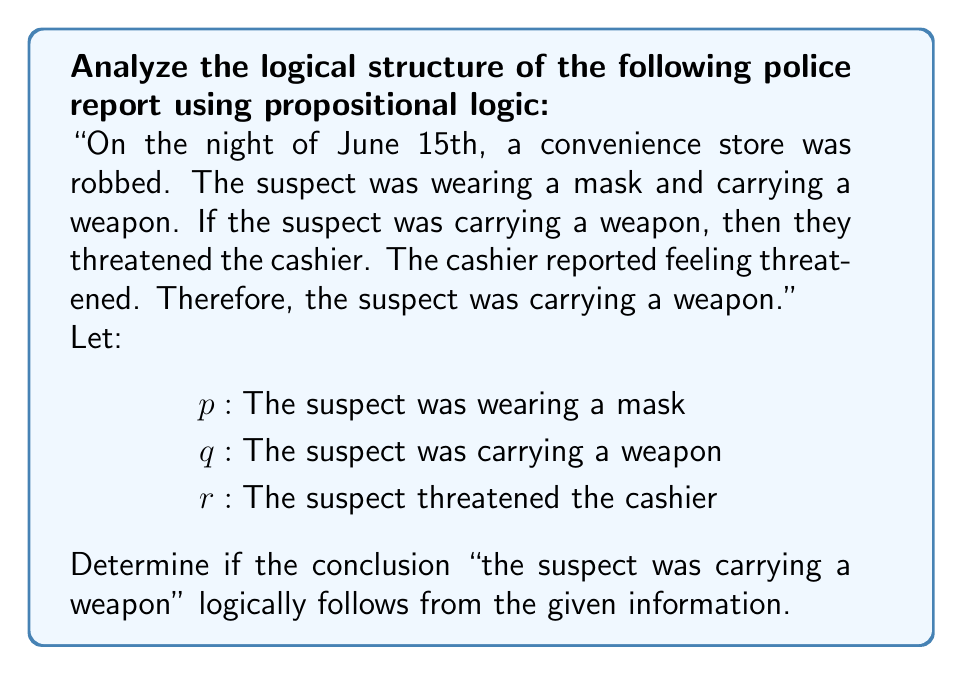What is the answer to this math problem? Let's break down the logical structure of the police report using propositional logic:

1. We have three propositions:
   $p$: The suspect was wearing a mask
   $q$: The suspect was carrying a weapon
   $r$: The suspect threatened the cashier

2. The report states: "If the suspect was carrying a weapon, then they threatened the cashier."
   This can be represented as: $q \rightarrow r$

3. We're also told that "The cashier reported feeling threatened."
   This means: $r$ is true

4. The conclusion states: "Therefore, the suspect was carrying a weapon."
   This claims: $q$ is true

5. To determine if the conclusion logically follows, we need to check if it's a valid inference from the given information.

6. The logical structure of the argument is:
   Premise 1: $q \rightarrow r$
   Premise 2: $r$
   Conclusion: $q$

7. This form of argument is known as the fallacy of affirming the consequent:
   $$(q \rightarrow r) \land r \therefore q$$

8. This is not a valid logical inference. Just because the cashier felt threatened ($r$ is true) and a weapon would cause a threat ($q \rightarrow r$), it doesn't necessarily mean a weapon was present.

9. There could be other reasons the cashier felt threatened that don't involve a weapon.

10. Therefore, the conclusion "the suspect was carrying a weapon" does not logically follow from the given information.
Answer: Invalid inference (affirming the consequent) 